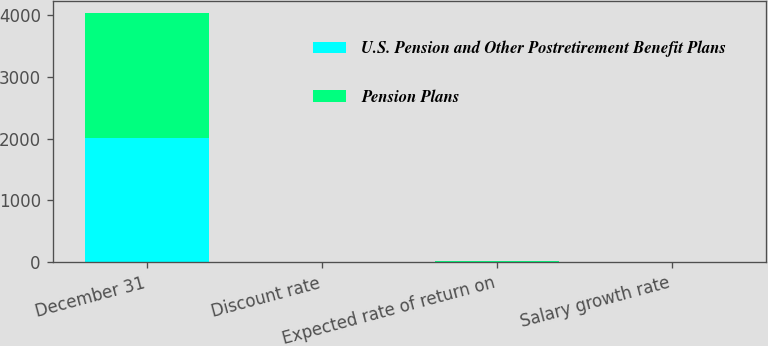Convert chart. <chart><loc_0><loc_0><loc_500><loc_500><stacked_bar_chart><ecel><fcel>December 31<fcel>Discount rate<fcel>Expected rate of return on<fcel>Salary growth rate<nl><fcel>U.S. Pension and Other Postretirement Benefit Plans<fcel>2011<fcel>5.2<fcel>7.5<fcel>4.2<nl><fcel>Pension Plans<fcel>2011<fcel>5.4<fcel>8.7<fcel>4.5<nl></chart> 